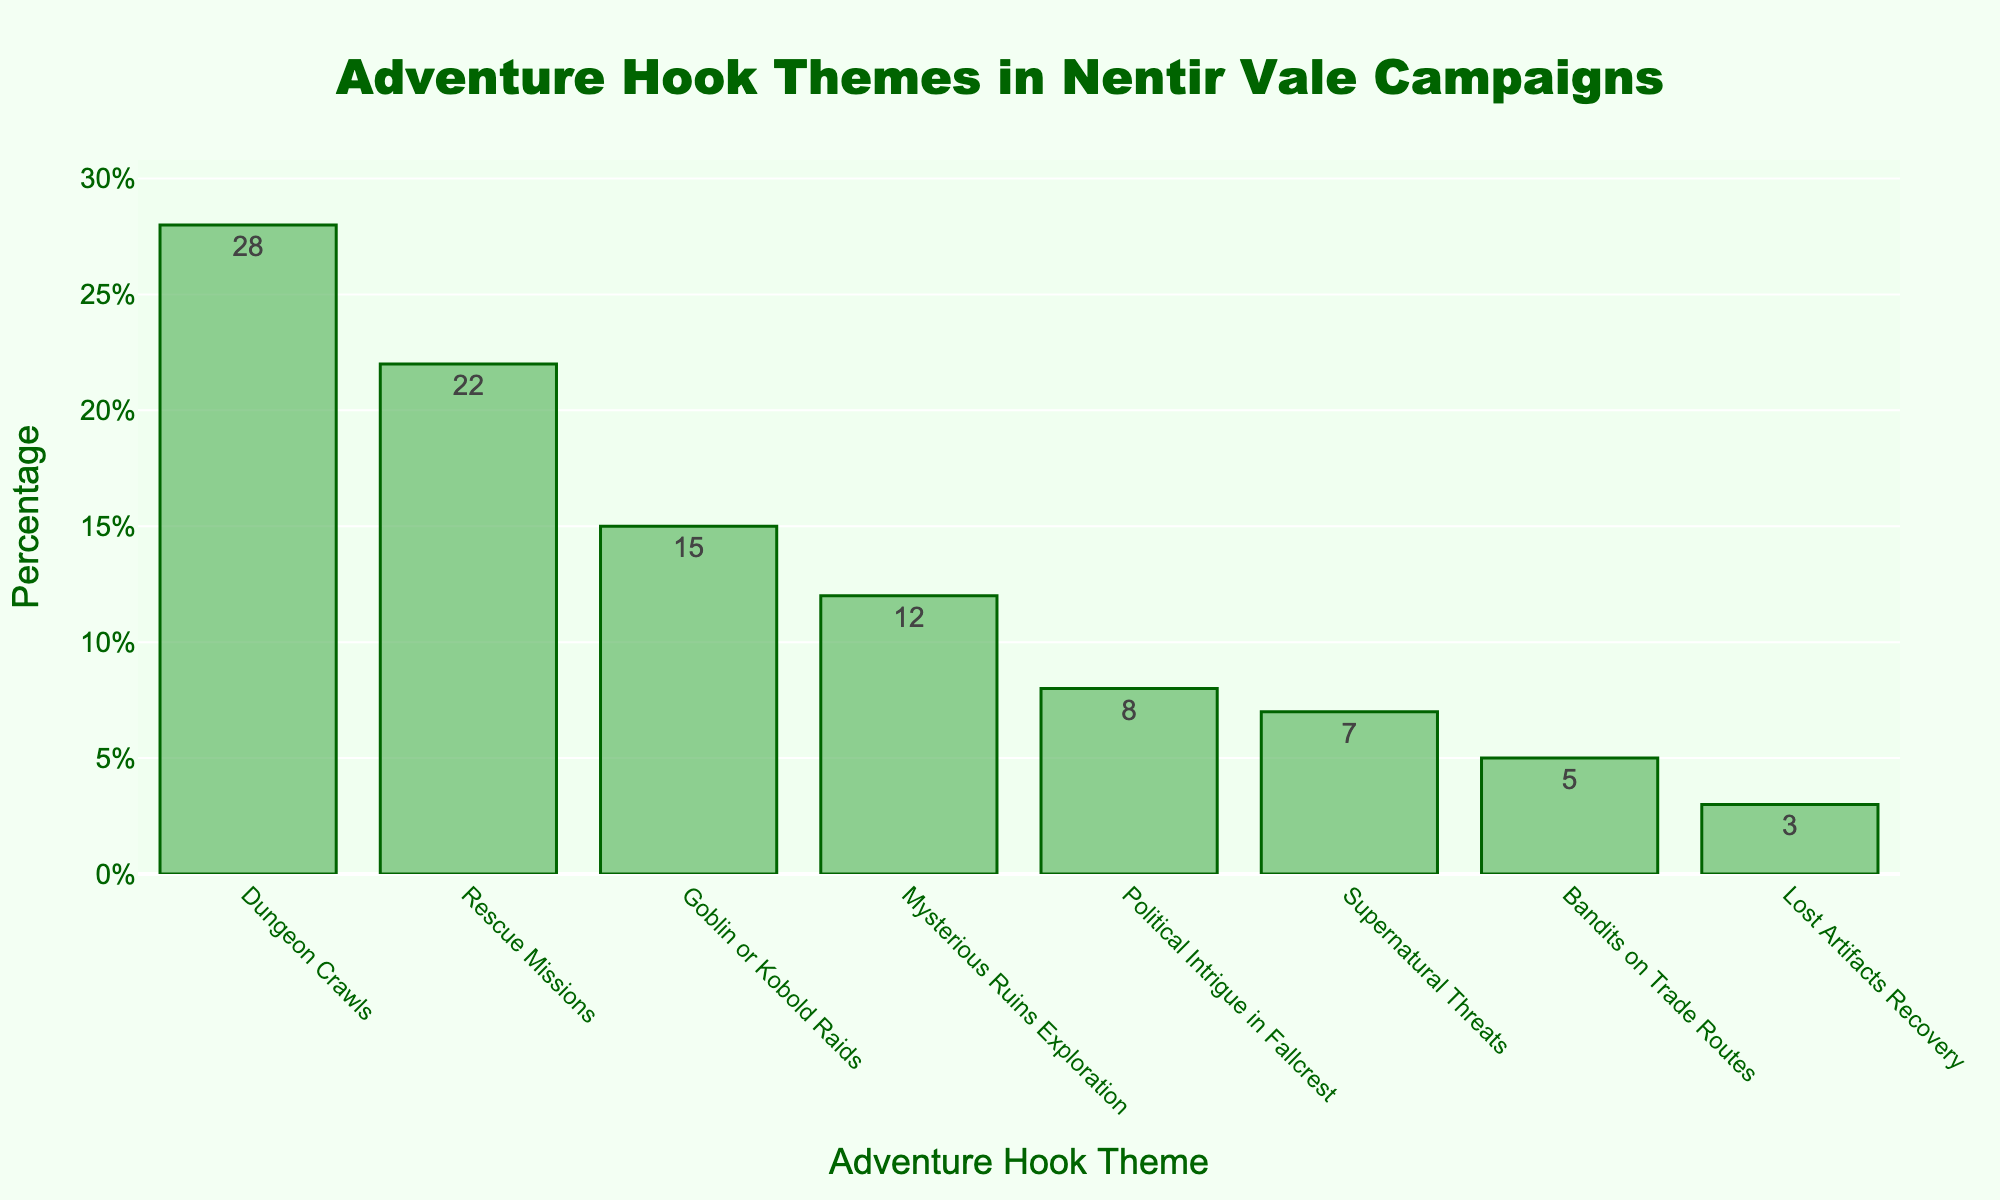What's the most common adventure hook theme used by DMs in Nentir Vale campaigns? The highest bar in the chart represents the most common theme. The "Dungeon Crawls" bar is the tallest.
Answer: Dungeon Crawls How much more popular are "Dungeon Crawls" than "Political Intrigue in Fallcrest"? The bar for "Dungeon Crawls" is at 28% and the bar for "Political Intrigue in Fallcrest" is at 8%. The difference is 28% - 8% = 20%.
Answer: 20% What percentage of adventure hooks are related to rescue missions? The bar labeled "Rescue Missions" provides the percentage, which is 22%.
Answer: 22% Which themes account for more than 20% of the adventure hooks? Look for bars above the 20% line. Both "Dungeon Crawls" at 28% and "Rescue Missions" at 22% have values greater than 20%.
Answer: Dungeon Crawls, Rescue Missions Are there more adventure hooks related to "Goblin or Kobold Raids" or "Mysterious Ruins Exploration"? Compare the heights of the bars. "Goblin or Kobold Raids" is at 15%, while "Mysterious Ruins Exploration" is at 12%. 15% is greater than 12%.
Answer: Goblin or Kobold Raids What is the combined percentage of "Lost Artifacts Recovery" and "Bandits on Trade Routes" themes? Sum the percentages for both themes: 3% (Lost Artifacts Recovery) + 5% (Bandits on Trade Routes) = 8%.
Answer: 8% Which adventure hook theme makes up the smallest percentage and what is that percentage? Identify the shortest bar. The shortest bar represents "Lost Artifacts Recovery," which is at 3%.
Answer: Lost Artifacts Recovery, 3% How do the percentages of "Rescue Missions" and "Supernatural Threats" compare? "Rescue Missions" has a percentage of 22%, while "Supernatural Threats" is at 7%. Rescue Missions is greater by 15%.
Answer: Rescue Missions are more common by 15% What is the average percentage of all adventure hook themes shown? Sum all the percentages and divide by the number of themes: (28 + 22 + 15 + 12 + 8 + 7 + 5 + 3) / 8 = 12.5%.
Answer: 12.5% How many adventure hook themes have percentages less than 10%? Count the bars with values less than 10%. Themes "Political Intrigue in Fallcrest," "Supernatural Threats," "Bandits on Trade Routes," and "Lost Artifacts Recovery" have values below 10%.
Answer: 4 